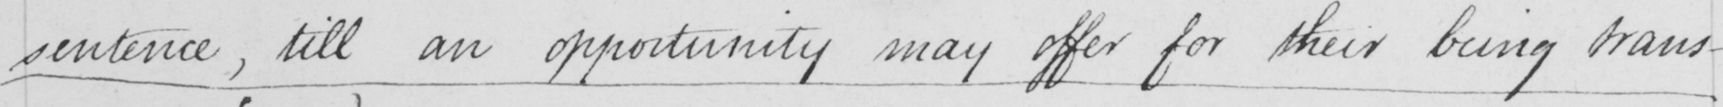What is written in this line of handwriting? sentence , till an opportunity may offer for their being trans- 